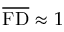<formula> <loc_0><loc_0><loc_500><loc_500>\overline { F D } \approx 1</formula> 